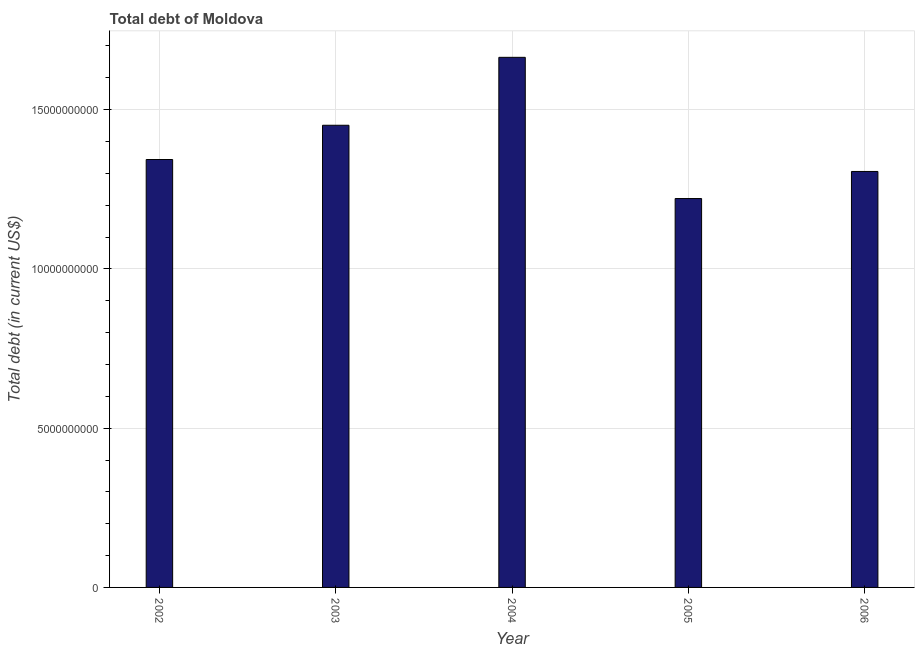Does the graph contain any zero values?
Make the answer very short. No. Does the graph contain grids?
Your answer should be very brief. Yes. What is the title of the graph?
Offer a terse response. Total debt of Moldova. What is the label or title of the X-axis?
Provide a short and direct response. Year. What is the label or title of the Y-axis?
Provide a short and direct response. Total debt (in current US$). What is the total debt in 2005?
Make the answer very short. 1.22e+1. Across all years, what is the maximum total debt?
Your response must be concise. 1.66e+1. Across all years, what is the minimum total debt?
Give a very brief answer. 1.22e+1. In which year was the total debt maximum?
Your answer should be compact. 2004. What is the sum of the total debt?
Provide a succinct answer. 6.99e+1. What is the difference between the total debt in 2005 and 2006?
Give a very brief answer. -8.50e+08. What is the average total debt per year?
Give a very brief answer. 1.40e+1. What is the median total debt?
Your answer should be compact. 1.34e+1. Do a majority of the years between 2002 and 2005 (inclusive) have total debt greater than 9000000000 US$?
Make the answer very short. Yes. What is the ratio of the total debt in 2003 to that in 2005?
Your answer should be compact. 1.19. Is the total debt in 2002 less than that in 2004?
Provide a short and direct response. Yes. Is the difference between the total debt in 2004 and 2006 greater than the difference between any two years?
Offer a very short reply. No. What is the difference between the highest and the second highest total debt?
Provide a succinct answer. 2.13e+09. What is the difference between the highest and the lowest total debt?
Offer a very short reply. 4.43e+09. In how many years, is the total debt greater than the average total debt taken over all years?
Provide a short and direct response. 2. How many bars are there?
Your response must be concise. 5. Are all the bars in the graph horizontal?
Provide a succinct answer. No. How many years are there in the graph?
Provide a succinct answer. 5. What is the difference between two consecutive major ticks on the Y-axis?
Make the answer very short. 5.00e+09. What is the Total debt (in current US$) of 2002?
Offer a very short reply. 1.34e+1. What is the Total debt (in current US$) of 2003?
Your answer should be compact. 1.45e+1. What is the Total debt (in current US$) in 2004?
Give a very brief answer. 1.66e+1. What is the Total debt (in current US$) in 2005?
Provide a short and direct response. 1.22e+1. What is the Total debt (in current US$) in 2006?
Your answer should be compact. 1.31e+1. What is the difference between the Total debt (in current US$) in 2002 and 2003?
Ensure brevity in your answer.  -1.08e+09. What is the difference between the Total debt (in current US$) in 2002 and 2004?
Ensure brevity in your answer.  -3.21e+09. What is the difference between the Total debt (in current US$) in 2002 and 2005?
Ensure brevity in your answer.  1.23e+09. What is the difference between the Total debt (in current US$) in 2002 and 2006?
Make the answer very short. 3.75e+08. What is the difference between the Total debt (in current US$) in 2003 and 2004?
Keep it short and to the point. -2.13e+09. What is the difference between the Total debt (in current US$) in 2003 and 2005?
Offer a very short reply. 2.30e+09. What is the difference between the Total debt (in current US$) in 2003 and 2006?
Your answer should be compact. 1.45e+09. What is the difference between the Total debt (in current US$) in 2004 and 2005?
Your answer should be compact. 4.43e+09. What is the difference between the Total debt (in current US$) in 2004 and 2006?
Your answer should be compact. 3.58e+09. What is the difference between the Total debt (in current US$) in 2005 and 2006?
Your answer should be compact. -8.50e+08. What is the ratio of the Total debt (in current US$) in 2002 to that in 2003?
Keep it short and to the point. 0.93. What is the ratio of the Total debt (in current US$) in 2002 to that in 2004?
Make the answer very short. 0.81. What is the ratio of the Total debt (in current US$) in 2002 to that in 2006?
Provide a succinct answer. 1.03. What is the ratio of the Total debt (in current US$) in 2003 to that in 2004?
Your answer should be very brief. 0.87. What is the ratio of the Total debt (in current US$) in 2003 to that in 2005?
Your answer should be compact. 1.19. What is the ratio of the Total debt (in current US$) in 2003 to that in 2006?
Give a very brief answer. 1.11. What is the ratio of the Total debt (in current US$) in 2004 to that in 2005?
Provide a short and direct response. 1.36. What is the ratio of the Total debt (in current US$) in 2004 to that in 2006?
Offer a terse response. 1.27. What is the ratio of the Total debt (in current US$) in 2005 to that in 2006?
Provide a short and direct response. 0.94. 